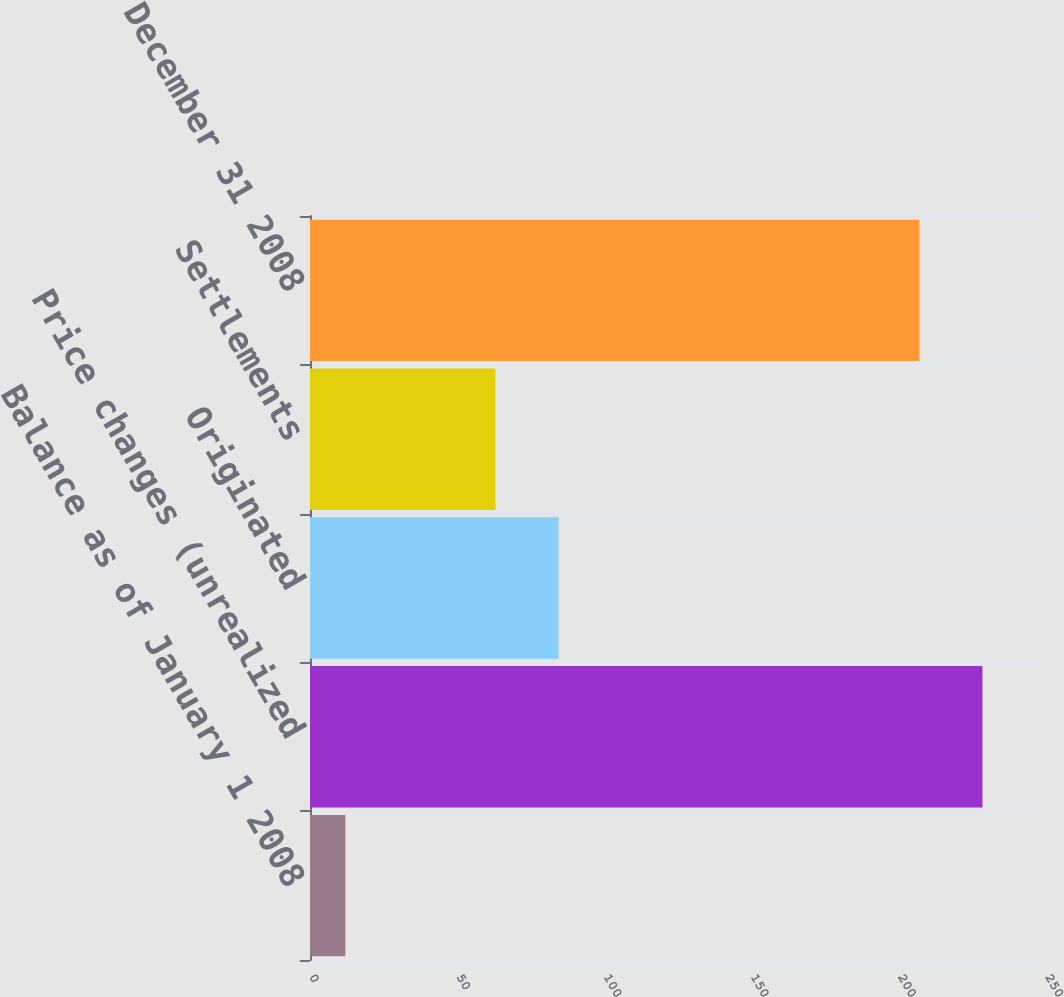Convert chart to OTSL. <chart><loc_0><loc_0><loc_500><loc_500><bar_chart><fcel>Balance as of January 1 2008<fcel>Price changes (unrealized<fcel>Originated<fcel>Settlements<fcel>Balance as of December 31 2008<nl><fcel>12<fcel>228.4<fcel>84.4<fcel>63<fcel>207<nl></chart> 